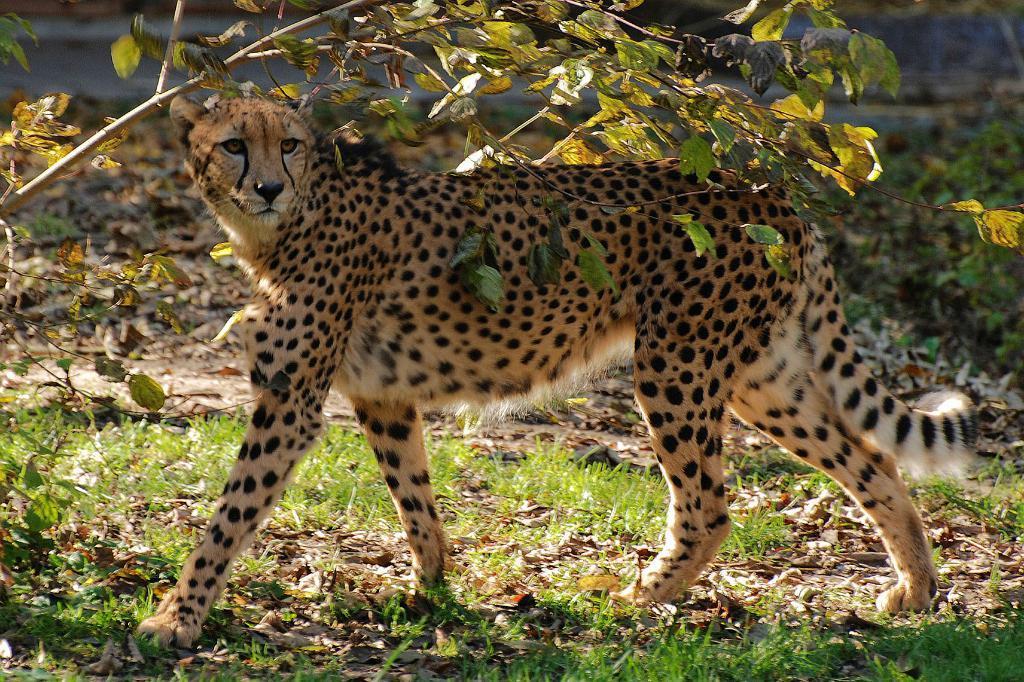Can you describe this image briefly? In this picture we can observe a cheetah on the land. We can observe some grass on the ground. There are some dried leaves. We can observe a small tree here. 